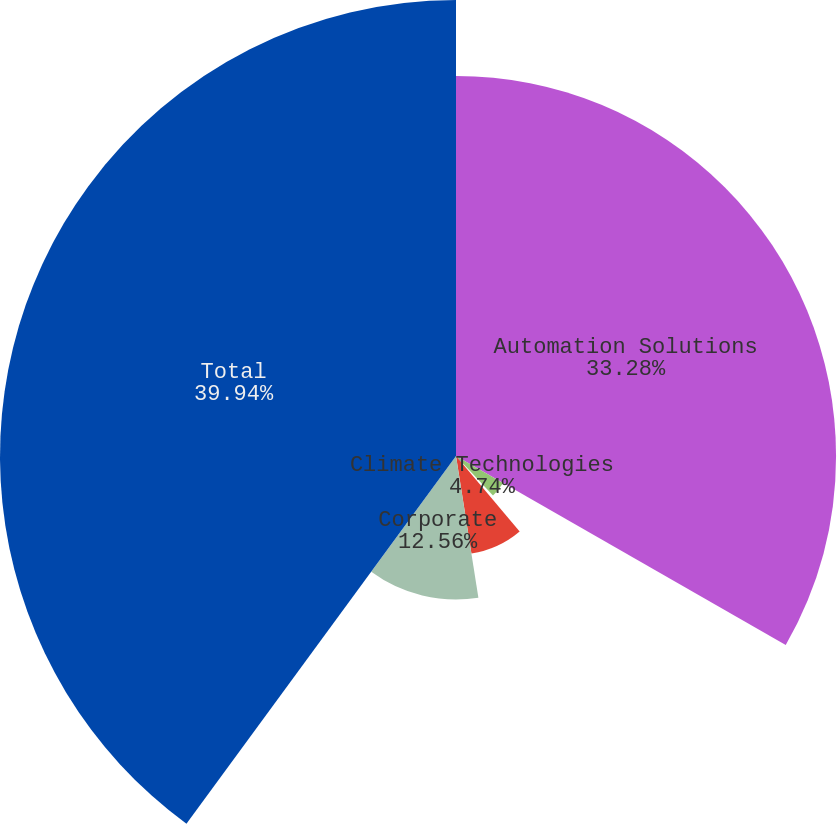Convert chart. <chart><loc_0><loc_0><loc_500><loc_500><pie_chart><fcel>Automation Solutions<fcel>Climate Technologies<fcel>Tools & Home Products<fcel>Commercial & Residential<fcel>Corporate<fcel>Total<nl><fcel>33.28%<fcel>4.74%<fcel>0.83%<fcel>8.65%<fcel>12.56%<fcel>39.93%<nl></chart> 